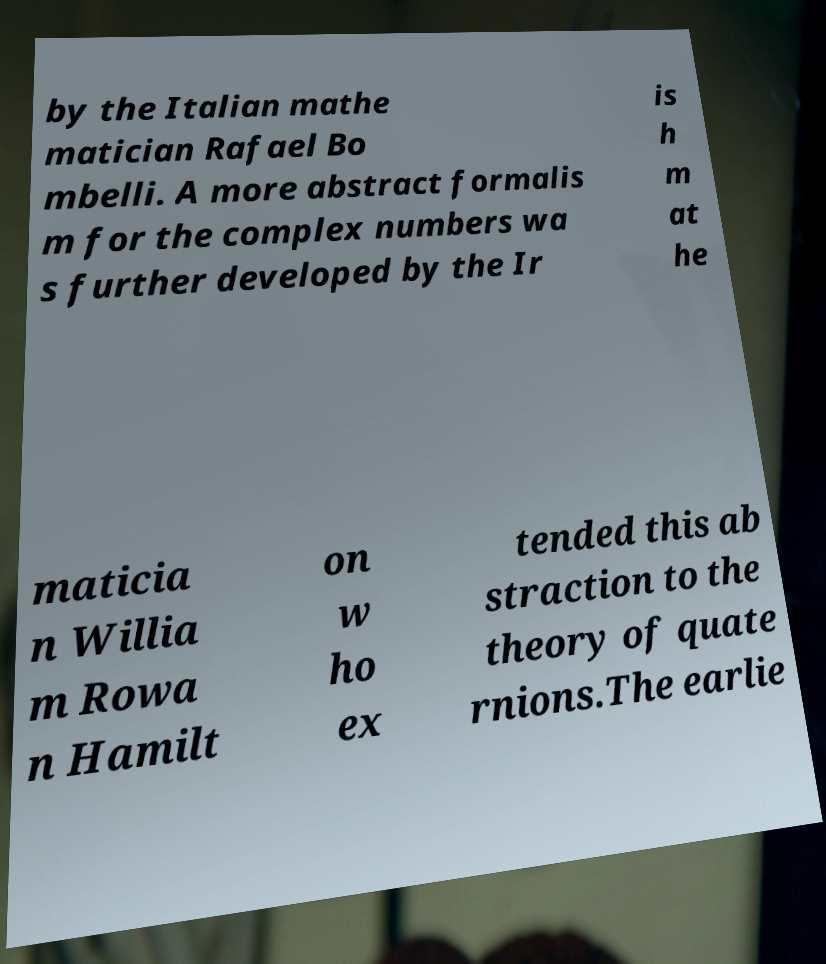Can you read and provide the text displayed in the image?This photo seems to have some interesting text. Can you extract and type it out for me? by the Italian mathe matician Rafael Bo mbelli. A more abstract formalis m for the complex numbers wa s further developed by the Ir is h m at he maticia n Willia m Rowa n Hamilt on w ho ex tended this ab straction to the theory of quate rnions.The earlie 